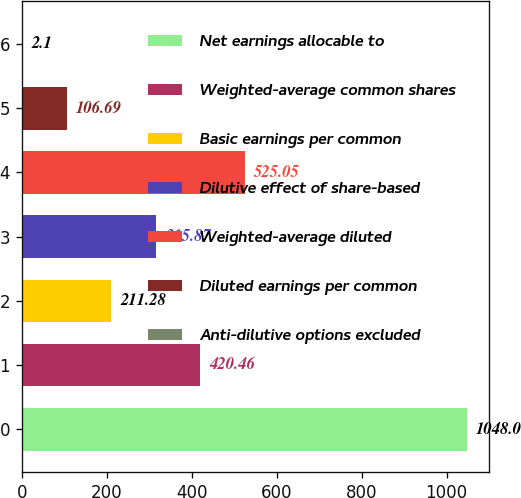<chart> <loc_0><loc_0><loc_500><loc_500><bar_chart><fcel>Net earnings allocable to<fcel>Weighted-average common shares<fcel>Basic earnings per common<fcel>Dilutive effect of share-based<fcel>Weighted-average diluted<fcel>Diluted earnings per common<fcel>Anti-dilutive options excluded<nl><fcel>1048<fcel>420.46<fcel>211.28<fcel>315.87<fcel>525.05<fcel>106.69<fcel>2.1<nl></chart> 